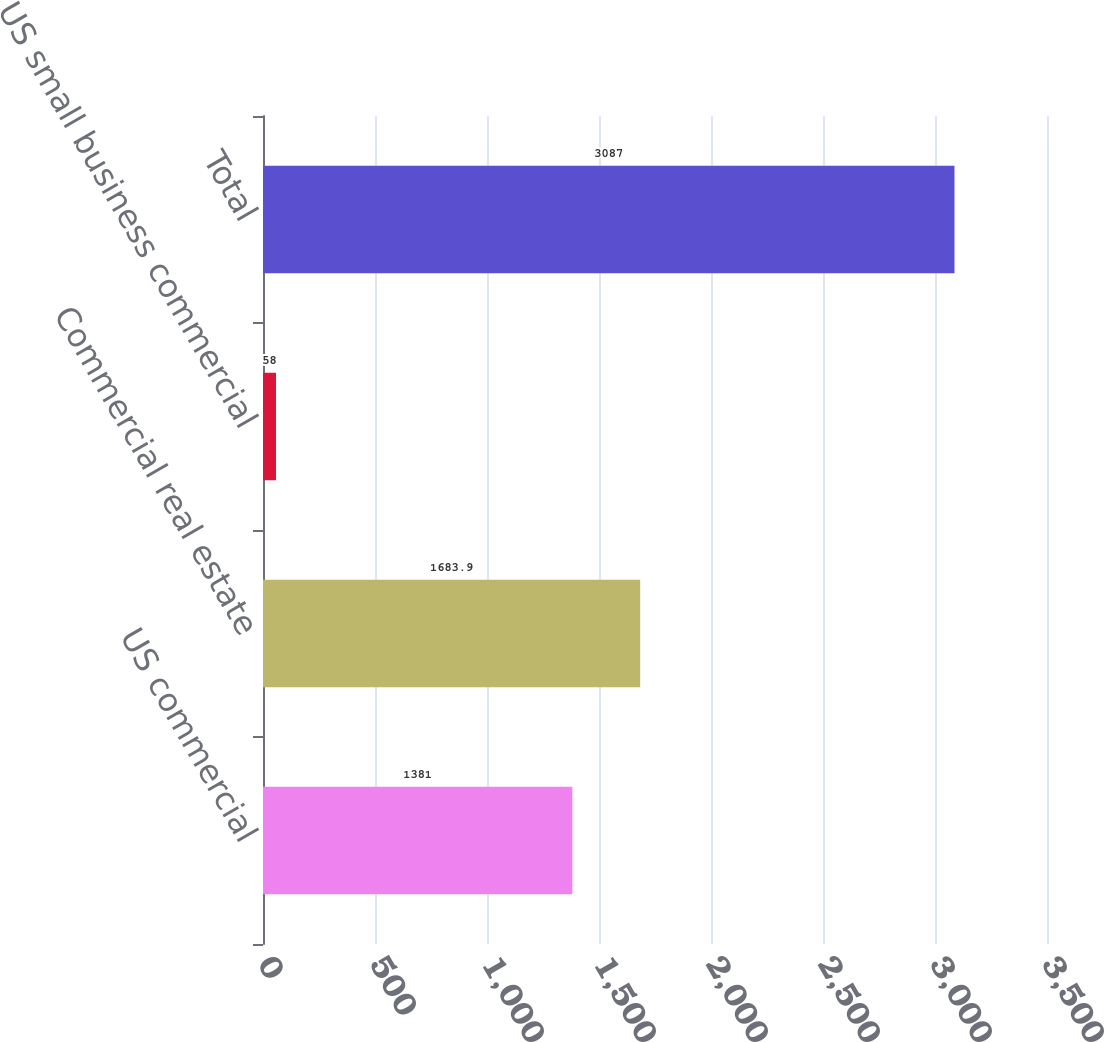Convert chart to OTSL. <chart><loc_0><loc_0><loc_500><loc_500><bar_chart><fcel>US commercial<fcel>Commercial real estate<fcel>US small business commercial<fcel>Total<nl><fcel>1381<fcel>1683.9<fcel>58<fcel>3087<nl></chart> 